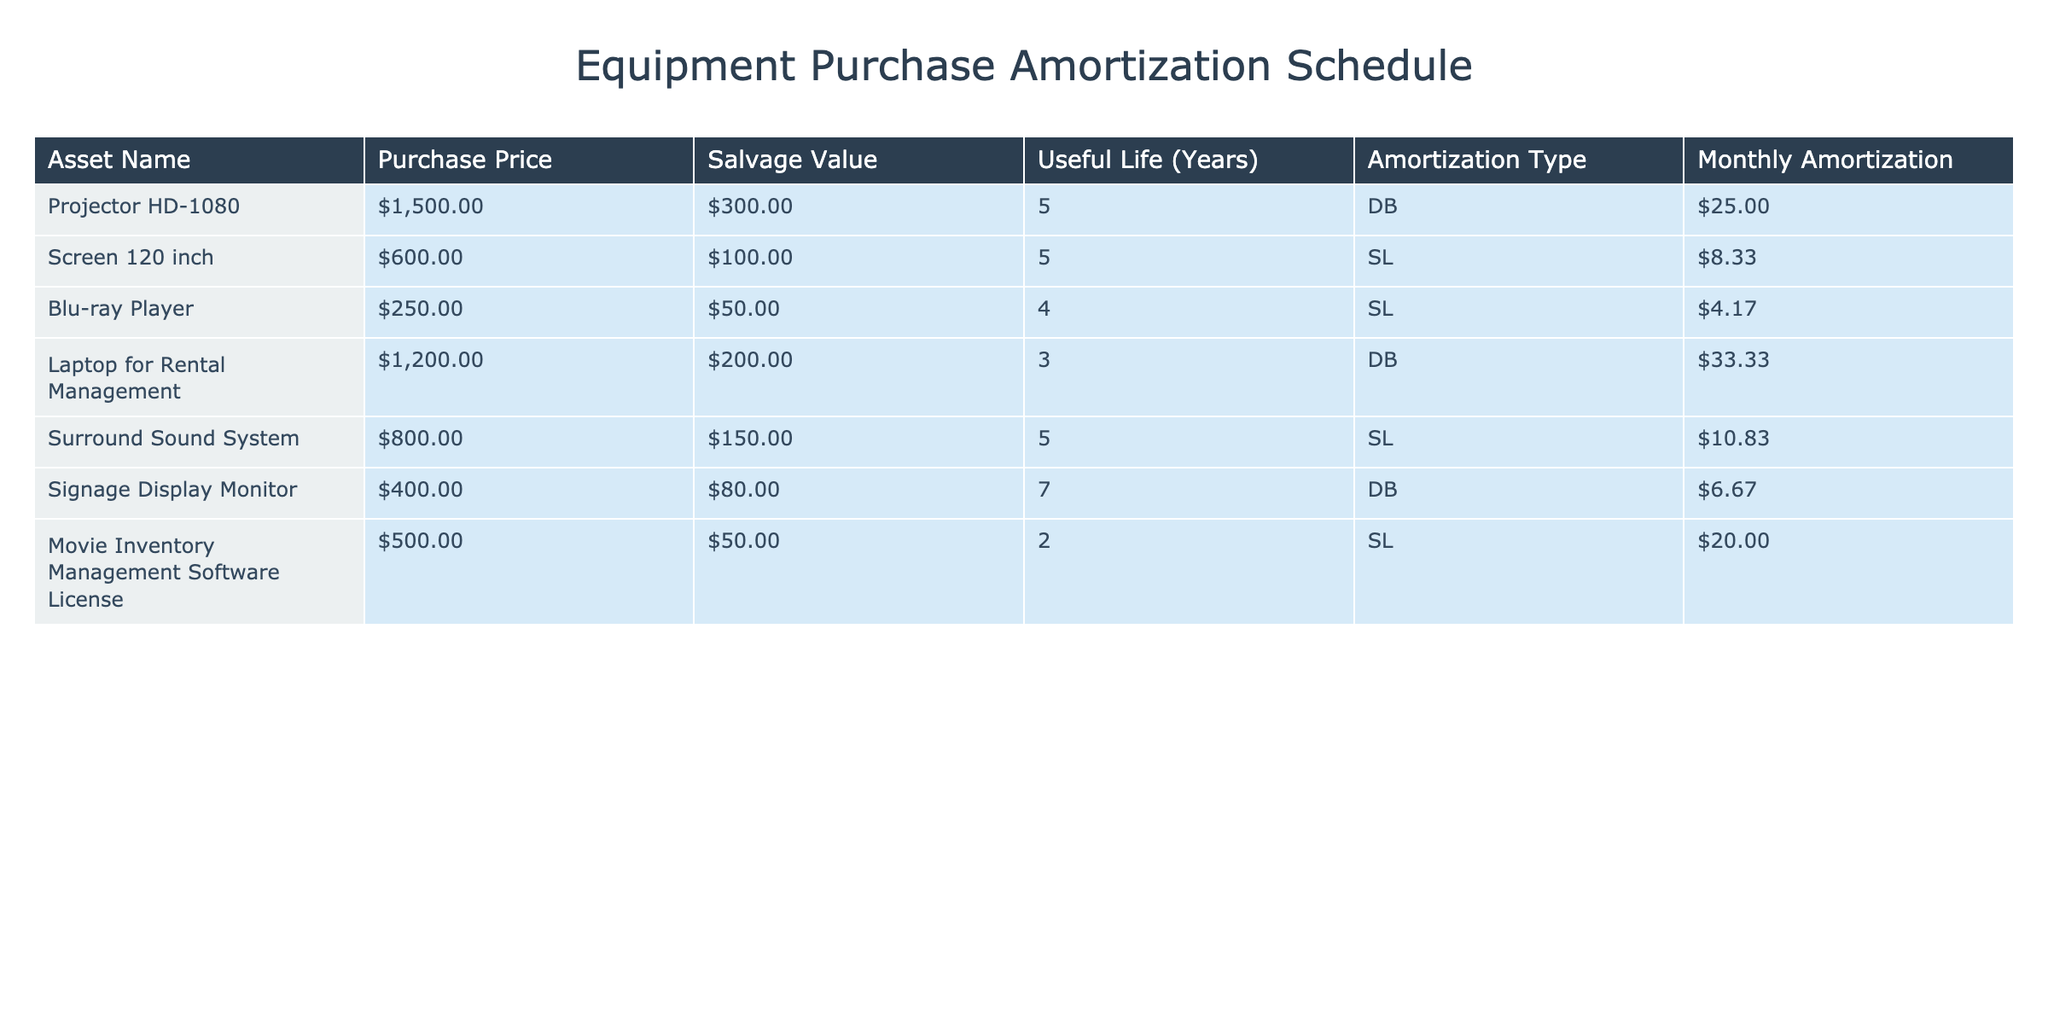What is the purchase price of the Blu-ray Player? The purchase price is listed directly in the table under 'Purchase Price' for the Blu-ray Player row. It shows $250.00.
Answer: $250.00 What is the monthly amortization for the Screen 120 inch? The monthly amortization can be found in the table by locating the Screen 120 inch row, which states $8.33.
Answer: $8.33 What is the total monthly amortization for all equipment combined? To find the total monthly amortization, I need to add together all monthly amortization values: (25.00 + 8.33 + 4.17 + 33.33 + 10.83 + 6.67 + 20.00) which equals $108.33.
Answer: $108.33 Is the salvage value of the Surround Sound System greater than that of the Projector HD-1080? According to the table, the salvage value of the Surround Sound System is $150.00 and that of the Projector HD-1080 is $300.00. Thus, the statement is false.
Answer: False Which equipment has the shortest useful life? By examining the 'Useful Life (Years)' column, I see that the Movie Inventory Management Software License has a useful life of 2 years, which is the shortest compared to the others.
Answer: Movie Inventory Management Software License What is the average monthly amortization for equipment with a Declining Balance amortization type? First, I find the monthly amortization values for Declining Balance equipment: Projector HD-1080 ($25.00) and Laptop for Rental Management ($33.33). Next, I compute the average: (25.00 + 33.33) / 2 = 29.17.
Answer: $29.17 Which equipment has the highest monthly amortization, and what is that amount? Checking the 'Monthly Amortization' column, the Laptop for Rental Management, at $33.33, has the highest monthly amortization.
Answer: Laptop for Rental Management, $33.33 Does any equipment have a salvage value that is less than $100? By reviewing the 'Salvage Value' column, the Blu-ray Player has a salvage value of $50.00 and the Movie Inventory Management Software License has a salvage value of $50.00, both less than $100. So, the answer is yes.
Answer: Yes What is the difference in purchase price between the Projector HD-1080 and the Screen 120 inch? From the table, the purchase price of the Projector HD-1080 is $1500.00 and that of the Screen 120 inch is $600.00. The difference is 1500.00 - 600.00 = $900.00.
Answer: $900.00 